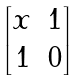<formula> <loc_0><loc_0><loc_500><loc_500>\begin{bmatrix} x & 1 \\ 1 & 0 \end{bmatrix}</formula> 